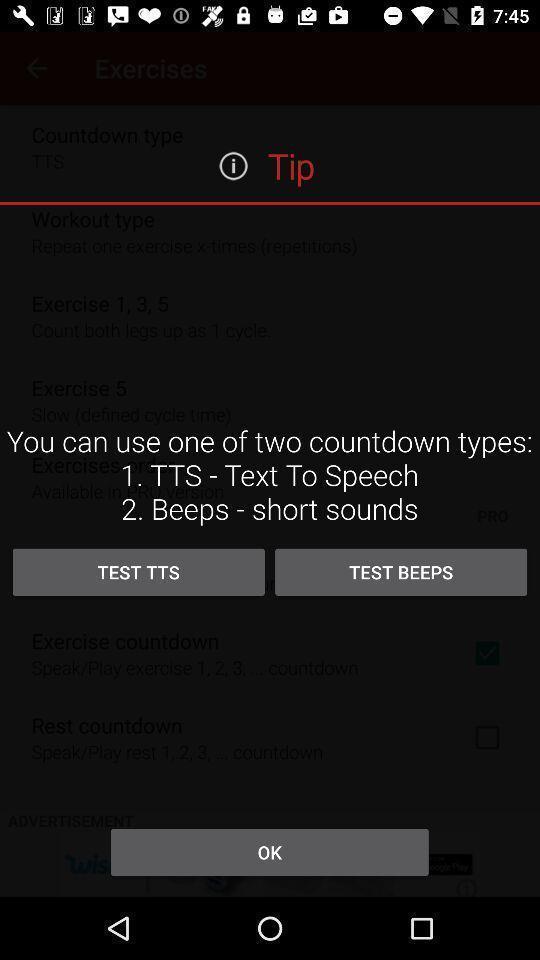Provide a description of this screenshot. Screen showing tip. 